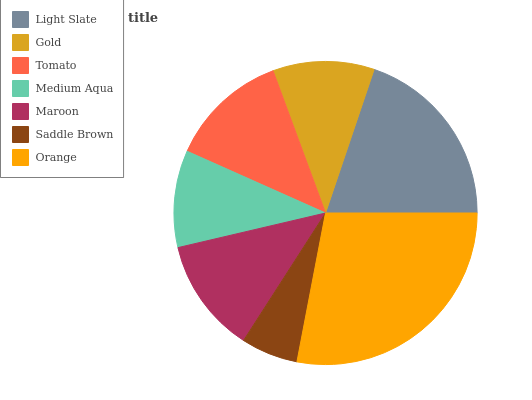Is Saddle Brown the minimum?
Answer yes or no. Yes. Is Orange the maximum?
Answer yes or no. Yes. Is Gold the minimum?
Answer yes or no. No. Is Gold the maximum?
Answer yes or no. No. Is Light Slate greater than Gold?
Answer yes or no. Yes. Is Gold less than Light Slate?
Answer yes or no. Yes. Is Gold greater than Light Slate?
Answer yes or no. No. Is Light Slate less than Gold?
Answer yes or no. No. Is Maroon the high median?
Answer yes or no. Yes. Is Maroon the low median?
Answer yes or no. Yes. Is Light Slate the high median?
Answer yes or no. No. Is Gold the low median?
Answer yes or no. No. 